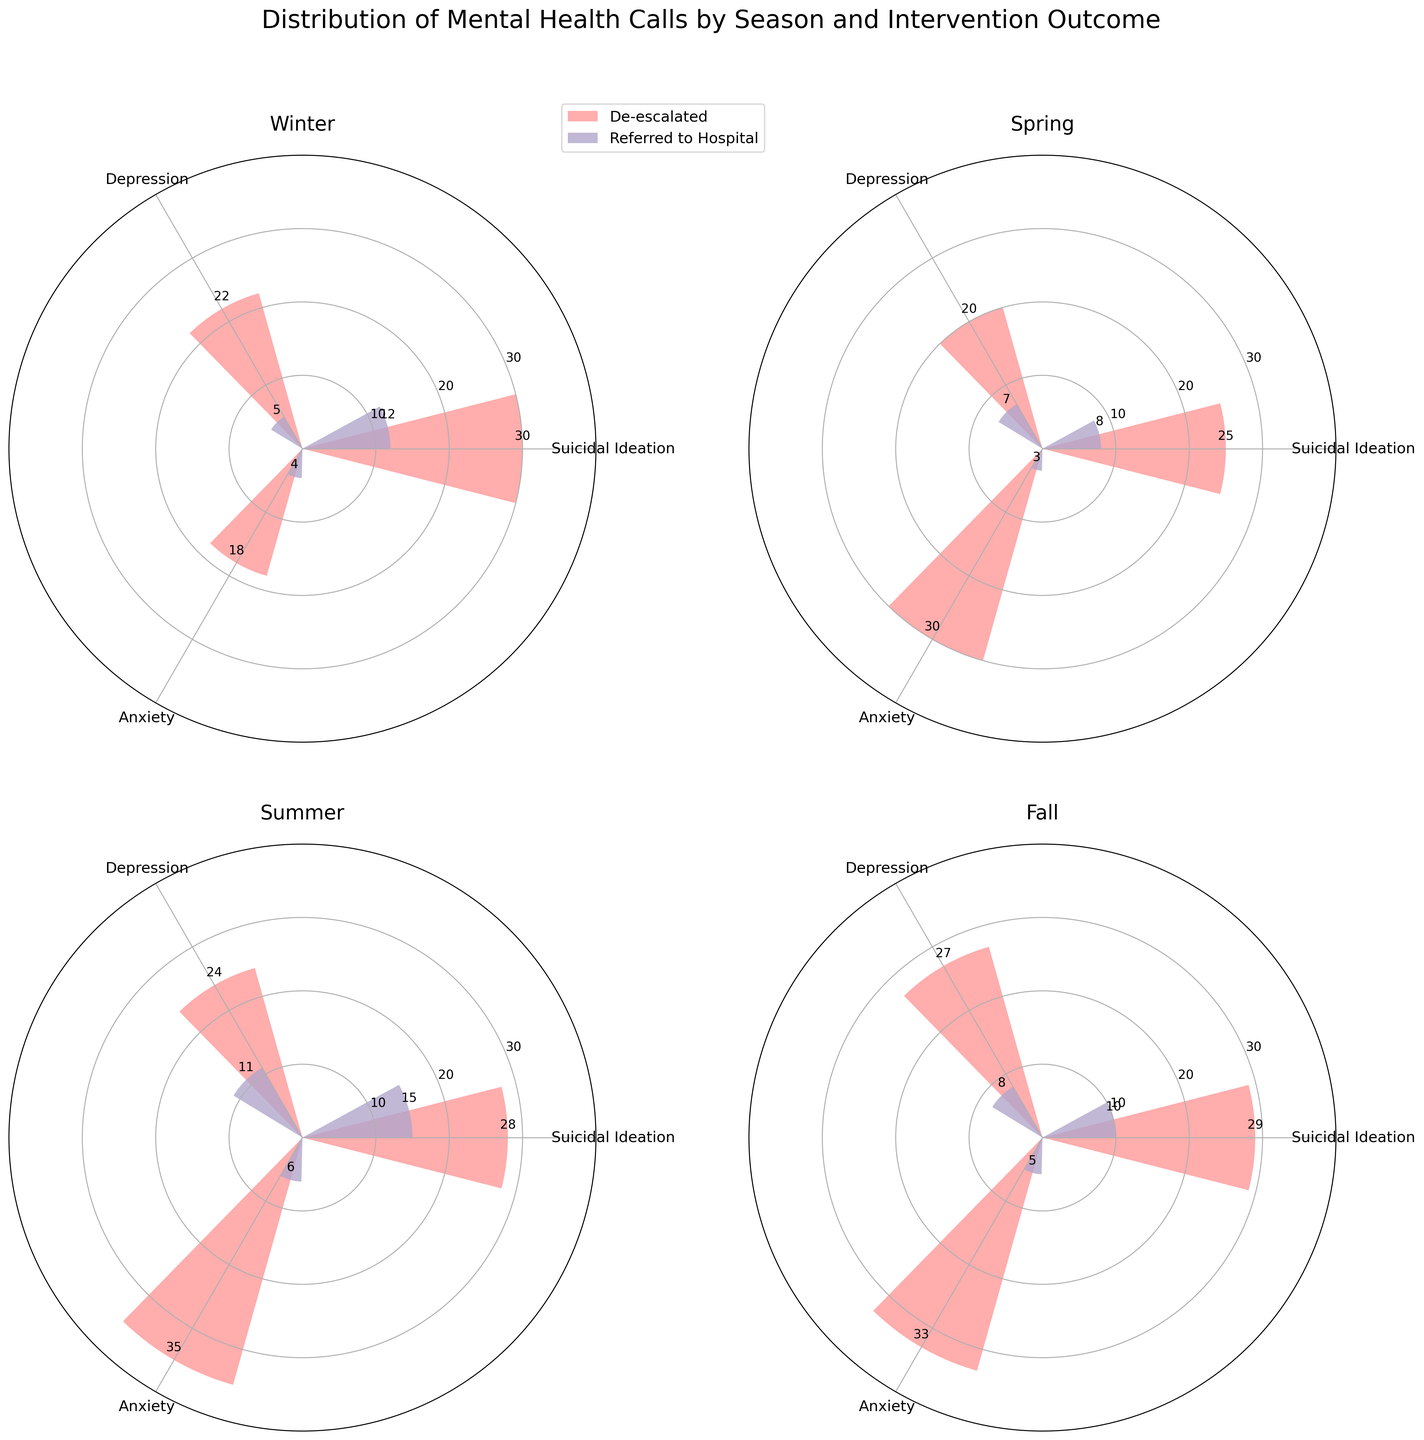What is the title of the figure? The title of the figure can typically be found at the top of the plot and provides the overall context for the data being visualized.
Answer: Distribution of Mental Health Calls by Season and Intervention Outcome Which season has the highest number of de-escalated mental health calls for Anxiety? To find this, we look at the heights of the bars labeled 'Anxiety' for 'De-escalated' in each subplot (season). The tallest bar in this category is in the Summer subplot.
Answer: Summer How many Suicidal Ideation calls were referred to the hospital in Spring? Look at the relevant bar in the Spring subplot for Suicidal Ideation and Referred to Hospital. The bar label or its height gives the count.
Answer: 8 Compare the number of Depression calls that were de-escalated in Winter and Fall. Which season has more and by how much? Check and compare the bar heights or values labeled 'Depression' for 'De-escalated' in both Winter and Fall subplots. Winter has 22 and Fall has 27, so Fall has 5 more de-escalated calls.
Answer: Fall, by 5 Across all seasons, which mental health issue has the most de-escalated calls? Sum the number of de-escalated calls for each mental health issue across all seasons and compare. Anxiety has the highest sum (18 + 30 + 35 + 33 = 116).
Answer: Anxiety In which season are the calls for Depression that were referred to the hospital the least? Check the bar representing 'Depression' that was referred to the hospital in each season and find the one with the lowest value. Winter has the least, with a count of 5.
Answer: Winter What is the total number of Suicidal Ideation calls referred to the hospital across all seasons? Sum the referrals to the hospital for Suicidal Ideation from each season: 12 (Winter) + 8 (Spring) + 15 (Summer) + 10 (Fall) = 45.
Answer: 45 How does the count of de-escalated Anxiety calls in Spring compare to that in Winter? Compare the heights of the relevant bars in Spring and Winter. Spring has 30, and Winter has 18, so Spring has 12 more de-escalated Anxiety calls.
Answer: Spring has 12 more What is the overall trend in the number of mental health calls that were referred to the hospital from Winter to Fall? Observing the overall height and number of 'Referred to Hospital' bars across Winter, Spring, Summer, and Fall, it appears there is an increase from Winter to Summer, followed by a slight decrease in Fall.
Answer: Increase then slight decrease Which season has the highest total number of mental health calls for Depression? Add up the counts for both de-escalated and hospital-referred Depression calls in each season. Winter has 22+5=27, Spring has 20+7=27, Summer has 24+11=35, and Fall has 27+8=35. So Summer and Fall both have the highest numbers, 35 each.
Answer: Summer and Fall 